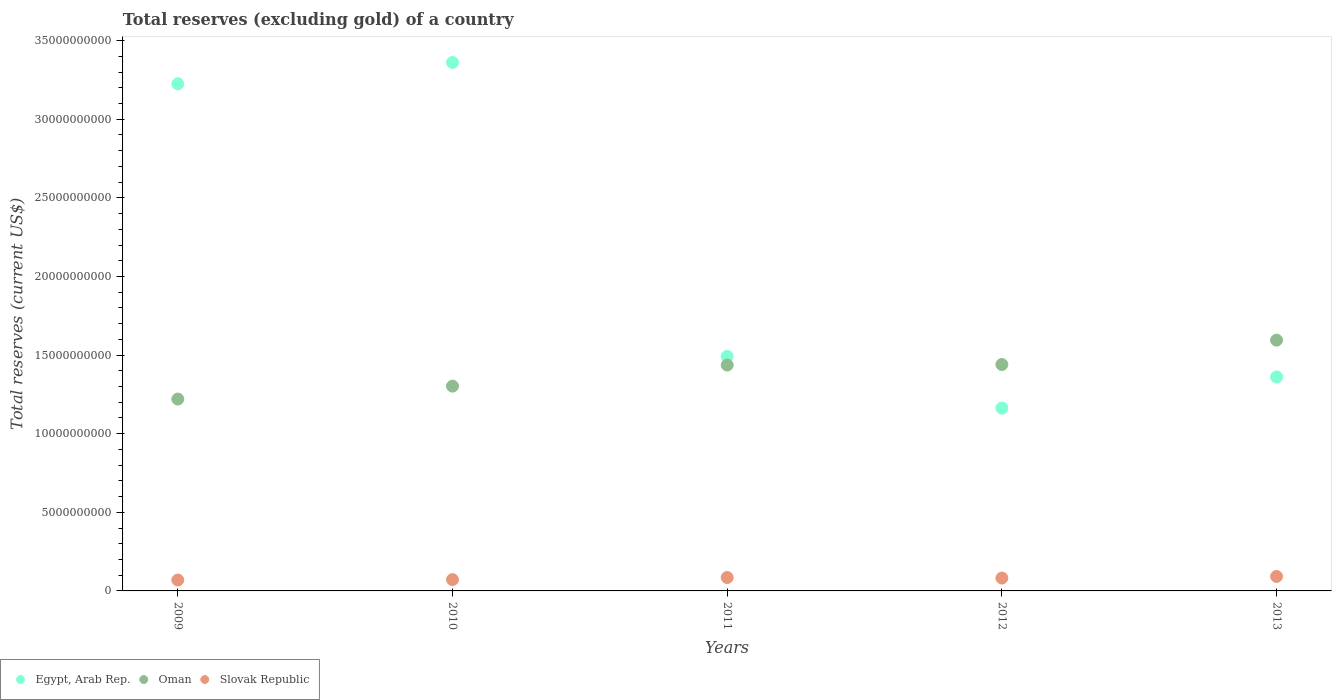What is the total reserves (excluding gold) in Oman in 2009?
Provide a short and direct response. 1.22e+1. Across all years, what is the maximum total reserves (excluding gold) in Egypt, Arab Rep.?
Make the answer very short. 3.36e+1. Across all years, what is the minimum total reserves (excluding gold) in Slovak Republic?
Your response must be concise. 6.92e+08. In which year was the total reserves (excluding gold) in Slovak Republic maximum?
Make the answer very short. 2013. What is the total total reserves (excluding gold) in Oman in the graph?
Make the answer very short. 6.99e+1. What is the difference between the total reserves (excluding gold) in Oman in 2009 and that in 2012?
Give a very brief answer. -2.20e+09. What is the difference between the total reserves (excluding gold) in Oman in 2010 and the total reserves (excluding gold) in Egypt, Arab Rep. in 2009?
Your answer should be compact. -1.92e+1. What is the average total reserves (excluding gold) in Slovak Republic per year?
Your response must be concise. 8.01e+08. In the year 2012, what is the difference between the total reserves (excluding gold) in Egypt, Arab Rep. and total reserves (excluding gold) in Oman?
Your answer should be very brief. -2.77e+09. In how many years, is the total reserves (excluding gold) in Oman greater than 26000000000 US$?
Ensure brevity in your answer.  0. What is the ratio of the total reserves (excluding gold) in Slovak Republic in 2010 to that in 2012?
Give a very brief answer. 0.88. Is the total reserves (excluding gold) in Oman in 2010 less than that in 2013?
Your response must be concise. Yes. Is the difference between the total reserves (excluding gold) in Egypt, Arab Rep. in 2009 and 2010 greater than the difference between the total reserves (excluding gold) in Oman in 2009 and 2010?
Provide a short and direct response. No. What is the difference between the highest and the second highest total reserves (excluding gold) in Oman?
Your answer should be compact. 1.55e+09. What is the difference between the highest and the lowest total reserves (excluding gold) in Egypt, Arab Rep.?
Your response must be concise. 2.20e+1. Is the sum of the total reserves (excluding gold) in Oman in 2010 and 2013 greater than the maximum total reserves (excluding gold) in Egypt, Arab Rep. across all years?
Give a very brief answer. No. Does the total reserves (excluding gold) in Slovak Republic monotonically increase over the years?
Give a very brief answer. No. Is the total reserves (excluding gold) in Egypt, Arab Rep. strictly greater than the total reserves (excluding gold) in Oman over the years?
Make the answer very short. No. Is the total reserves (excluding gold) in Oman strictly less than the total reserves (excluding gold) in Slovak Republic over the years?
Your answer should be compact. No. How many dotlines are there?
Make the answer very short. 3. How many years are there in the graph?
Your answer should be compact. 5. What is the difference between two consecutive major ticks on the Y-axis?
Offer a very short reply. 5.00e+09. What is the title of the graph?
Offer a terse response. Total reserves (excluding gold) of a country. Does "Croatia" appear as one of the legend labels in the graph?
Give a very brief answer. No. What is the label or title of the Y-axis?
Give a very brief answer. Total reserves (current US$). What is the Total reserves (current US$) in Egypt, Arab Rep. in 2009?
Give a very brief answer. 3.23e+1. What is the Total reserves (current US$) of Oman in 2009?
Provide a short and direct response. 1.22e+1. What is the Total reserves (current US$) in Slovak Republic in 2009?
Make the answer very short. 6.92e+08. What is the Total reserves (current US$) in Egypt, Arab Rep. in 2010?
Offer a terse response. 3.36e+1. What is the Total reserves (current US$) of Oman in 2010?
Make the answer very short. 1.30e+1. What is the Total reserves (current US$) in Slovak Republic in 2010?
Give a very brief answer. 7.19e+08. What is the Total reserves (current US$) in Egypt, Arab Rep. in 2011?
Ensure brevity in your answer.  1.49e+1. What is the Total reserves (current US$) in Oman in 2011?
Offer a terse response. 1.44e+1. What is the Total reserves (current US$) of Slovak Republic in 2011?
Offer a very short reply. 8.53e+08. What is the Total reserves (current US$) of Egypt, Arab Rep. in 2012?
Offer a terse response. 1.16e+1. What is the Total reserves (current US$) of Oman in 2012?
Keep it short and to the point. 1.44e+1. What is the Total reserves (current US$) in Slovak Republic in 2012?
Keep it short and to the point. 8.18e+08. What is the Total reserves (current US$) of Egypt, Arab Rep. in 2013?
Your answer should be compact. 1.36e+1. What is the Total reserves (current US$) of Oman in 2013?
Provide a short and direct response. 1.60e+1. What is the Total reserves (current US$) in Slovak Republic in 2013?
Your answer should be compact. 9.22e+08. Across all years, what is the maximum Total reserves (current US$) of Egypt, Arab Rep.?
Provide a succinct answer. 3.36e+1. Across all years, what is the maximum Total reserves (current US$) in Oman?
Offer a terse response. 1.60e+1. Across all years, what is the maximum Total reserves (current US$) in Slovak Republic?
Your answer should be very brief. 9.22e+08. Across all years, what is the minimum Total reserves (current US$) in Egypt, Arab Rep.?
Offer a very short reply. 1.16e+1. Across all years, what is the minimum Total reserves (current US$) of Oman?
Offer a very short reply. 1.22e+1. Across all years, what is the minimum Total reserves (current US$) in Slovak Republic?
Provide a succinct answer. 6.92e+08. What is the total Total reserves (current US$) of Egypt, Arab Rep. in the graph?
Your answer should be very brief. 1.06e+11. What is the total Total reserves (current US$) of Oman in the graph?
Your answer should be very brief. 6.99e+1. What is the total Total reserves (current US$) in Slovak Republic in the graph?
Give a very brief answer. 4.01e+09. What is the difference between the Total reserves (current US$) in Egypt, Arab Rep. in 2009 and that in 2010?
Make the answer very short. -1.36e+09. What is the difference between the Total reserves (current US$) in Oman in 2009 and that in 2010?
Ensure brevity in your answer.  -8.21e+08. What is the difference between the Total reserves (current US$) of Slovak Republic in 2009 and that in 2010?
Make the answer very short. -2.71e+07. What is the difference between the Total reserves (current US$) of Egypt, Arab Rep. in 2009 and that in 2011?
Make the answer very short. 1.73e+1. What is the difference between the Total reserves (current US$) of Oman in 2009 and that in 2011?
Your answer should be compact. -2.16e+09. What is the difference between the Total reserves (current US$) in Slovak Republic in 2009 and that in 2011?
Provide a succinct answer. -1.61e+08. What is the difference between the Total reserves (current US$) in Egypt, Arab Rep. in 2009 and that in 2012?
Your answer should be compact. 2.06e+1. What is the difference between the Total reserves (current US$) of Oman in 2009 and that in 2012?
Give a very brief answer. -2.20e+09. What is the difference between the Total reserves (current US$) of Slovak Republic in 2009 and that in 2012?
Offer a very short reply. -1.26e+08. What is the difference between the Total reserves (current US$) in Egypt, Arab Rep. in 2009 and that in 2013?
Your answer should be very brief. 1.86e+1. What is the difference between the Total reserves (current US$) of Oman in 2009 and that in 2013?
Keep it short and to the point. -3.75e+09. What is the difference between the Total reserves (current US$) in Slovak Republic in 2009 and that in 2013?
Provide a succinct answer. -2.30e+08. What is the difference between the Total reserves (current US$) in Egypt, Arab Rep. in 2010 and that in 2011?
Ensure brevity in your answer.  1.87e+1. What is the difference between the Total reserves (current US$) of Oman in 2010 and that in 2011?
Your answer should be compact. -1.34e+09. What is the difference between the Total reserves (current US$) in Slovak Republic in 2010 and that in 2011?
Provide a short and direct response. -1.34e+08. What is the difference between the Total reserves (current US$) of Egypt, Arab Rep. in 2010 and that in 2012?
Make the answer very short. 2.20e+1. What is the difference between the Total reserves (current US$) of Oman in 2010 and that in 2012?
Your answer should be very brief. -1.38e+09. What is the difference between the Total reserves (current US$) of Slovak Republic in 2010 and that in 2012?
Your answer should be very brief. -9.91e+07. What is the difference between the Total reserves (current US$) of Egypt, Arab Rep. in 2010 and that in 2013?
Keep it short and to the point. 2.00e+1. What is the difference between the Total reserves (current US$) of Oman in 2010 and that in 2013?
Ensure brevity in your answer.  -2.93e+09. What is the difference between the Total reserves (current US$) of Slovak Republic in 2010 and that in 2013?
Make the answer very short. -2.03e+08. What is the difference between the Total reserves (current US$) of Egypt, Arab Rep. in 2011 and that in 2012?
Your answer should be very brief. 3.29e+09. What is the difference between the Total reserves (current US$) of Oman in 2011 and that in 2012?
Make the answer very short. -3.48e+07. What is the difference between the Total reserves (current US$) in Slovak Republic in 2011 and that in 2012?
Your answer should be compact. 3.49e+07. What is the difference between the Total reserves (current US$) of Egypt, Arab Rep. in 2011 and that in 2013?
Your response must be concise. 1.31e+09. What is the difference between the Total reserves (current US$) of Oman in 2011 and that in 2013?
Provide a succinct answer. -1.59e+09. What is the difference between the Total reserves (current US$) of Slovak Republic in 2011 and that in 2013?
Offer a very short reply. -6.86e+07. What is the difference between the Total reserves (current US$) of Egypt, Arab Rep. in 2012 and that in 2013?
Ensure brevity in your answer.  -1.98e+09. What is the difference between the Total reserves (current US$) in Oman in 2012 and that in 2013?
Keep it short and to the point. -1.55e+09. What is the difference between the Total reserves (current US$) in Slovak Republic in 2012 and that in 2013?
Offer a terse response. -1.04e+08. What is the difference between the Total reserves (current US$) in Egypt, Arab Rep. in 2009 and the Total reserves (current US$) in Oman in 2010?
Keep it short and to the point. 1.92e+1. What is the difference between the Total reserves (current US$) in Egypt, Arab Rep. in 2009 and the Total reserves (current US$) in Slovak Republic in 2010?
Your response must be concise. 3.15e+1. What is the difference between the Total reserves (current US$) of Oman in 2009 and the Total reserves (current US$) of Slovak Republic in 2010?
Give a very brief answer. 1.15e+1. What is the difference between the Total reserves (current US$) of Egypt, Arab Rep. in 2009 and the Total reserves (current US$) of Oman in 2011?
Provide a succinct answer. 1.79e+1. What is the difference between the Total reserves (current US$) of Egypt, Arab Rep. in 2009 and the Total reserves (current US$) of Slovak Republic in 2011?
Offer a terse response. 3.14e+1. What is the difference between the Total reserves (current US$) of Oman in 2009 and the Total reserves (current US$) of Slovak Republic in 2011?
Your answer should be compact. 1.13e+1. What is the difference between the Total reserves (current US$) of Egypt, Arab Rep. in 2009 and the Total reserves (current US$) of Oman in 2012?
Your answer should be compact. 1.79e+1. What is the difference between the Total reserves (current US$) in Egypt, Arab Rep. in 2009 and the Total reserves (current US$) in Slovak Republic in 2012?
Offer a very short reply. 3.14e+1. What is the difference between the Total reserves (current US$) in Oman in 2009 and the Total reserves (current US$) in Slovak Republic in 2012?
Keep it short and to the point. 1.14e+1. What is the difference between the Total reserves (current US$) of Egypt, Arab Rep. in 2009 and the Total reserves (current US$) of Oman in 2013?
Offer a very short reply. 1.63e+1. What is the difference between the Total reserves (current US$) in Egypt, Arab Rep. in 2009 and the Total reserves (current US$) in Slovak Republic in 2013?
Your answer should be very brief. 3.13e+1. What is the difference between the Total reserves (current US$) in Oman in 2009 and the Total reserves (current US$) in Slovak Republic in 2013?
Ensure brevity in your answer.  1.13e+1. What is the difference between the Total reserves (current US$) of Egypt, Arab Rep. in 2010 and the Total reserves (current US$) of Oman in 2011?
Offer a terse response. 1.92e+1. What is the difference between the Total reserves (current US$) in Egypt, Arab Rep. in 2010 and the Total reserves (current US$) in Slovak Republic in 2011?
Your response must be concise. 3.28e+1. What is the difference between the Total reserves (current US$) in Oman in 2010 and the Total reserves (current US$) in Slovak Republic in 2011?
Provide a short and direct response. 1.22e+1. What is the difference between the Total reserves (current US$) in Egypt, Arab Rep. in 2010 and the Total reserves (current US$) in Oman in 2012?
Offer a very short reply. 1.92e+1. What is the difference between the Total reserves (current US$) in Egypt, Arab Rep. in 2010 and the Total reserves (current US$) in Slovak Republic in 2012?
Make the answer very short. 3.28e+1. What is the difference between the Total reserves (current US$) of Oman in 2010 and the Total reserves (current US$) of Slovak Republic in 2012?
Offer a very short reply. 1.22e+1. What is the difference between the Total reserves (current US$) in Egypt, Arab Rep. in 2010 and the Total reserves (current US$) in Oman in 2013?
Keep it short and to the point. 1.77e+1. What is the difference between the Total reserves (current US$) of Egypt, Arab Rep. in 2010 and the Total reserves (current US$) of Slovak Republic in 2013?
Your answer should be compact. 3.27e+1. What is the difference between the Total reserves (current US$) in Oman in 2010 and the Total reserves (current US$) in Slovak Republic in 2013?
Give a very brief answer. 1.21e+1. What is the difference between the Total reserves (current US$) in Egypt, Arab Rep. in 2011 and the Total reserves (current US$) in Oman in 2012?
Offer a terse response. 5.16e+08. What is the difference between the Total reserves (current US$) of Egypt, Arab Rep. in 2011 and the Total reserves (current US$) of Slovak Republic in 2012?
Keep it short and to the point. 1.41e+1. What is the difference between the Total reserves (current US$) in Oman in 2011 and the Total reserves (current US$) in Slovak Republic in 2012?
Your answer should be very brief. 1.35e+1. What is the difference between the Total reserves (current US$) of Egypt, Arab Rep. in 2011 and the Total reserves (current US$) of Oman in 2013?
Ensure brevity in your answer.  -1.03e+09. What is the difference between the Total reserves (current US$) in Egypt, Arab Rep. in 2011 and the Total reserves (current US$) in Slovak Republic in 2013?
Provide a succinct answer. 1.40e+1. What is the difference between the Total reserves (current US$) of Oman in 2011 and the Total reserves (current US$) of Slovak Republic in 2013?
Keep it short and to the point. 1.34e+1. What is the difference between the Total reserves (current US$) in Egypt, Arab Rep. in 2012 and the Total reserves (current US$) in Oman in 2013?
Your answer should be very brief. -4.32e+09. What is the difference between the Total reserves (current US$) in Egypt, Arab Rep. in 2012 and the Total reserves (current US$) in Slovak Republic in 2013?
Offer a very short reply. 1.07e+1. What is the difference between the Total reserves (current US$) in Oman in 2012 and the Total reserves (current US$) in Slovak Republic in 2013?
Your response must be concise. 1.35e+1. What is the average Total reserves (current US$) in Egypt, Arab Rep. per year?
Provide a short and direct response. 2.12e+1. What is the average Total reserves (current US$) of Oman per year?
Provide a succinct answer. 1.40e+1. What is the average Total reserves (current US$) in Slovak Republic per year?
Give a very brief answer. 8.01e+08. In the year 2009, what is the difference between the Total reserves (current US$) in Egypt, Arab Rep. and Total reserves (current US$) in Oman?
Offer a terse response. 2.01e+1. In the year 2009, what is the difference between the Total reserves (current US$) in Egypt, Arab Rep. and Total reserves (current US$) in Slovak Republic?
Your response must be concise. 3.16e+1. In the year 2009, what is the difference between the Total reserves (current US$) in Oman and Total reserves (current US$) in Slovak Republic?
Offer a very short reply. 1.15e+1. In the year 2010, what is the difference between the Total reserves (current US$) in Egypt, Arab Rep. and Total reserves (current US$) in Oman?
Keep it short and to the point. 2.06e+1. In the year 2010, what is the difference between the Total reserves (current US$) in Egypt, Arab Rep. and Total reserves (current US$) in Slovak Republic?
Give a very brief answer. 3.29e+1. In the year 2010, what is the difference between the Total reserves (current US$) in Oman and Total reserves (current US$) in Slovak Republic?
Offer a terse response. 1.23e+1. In the year 2011, what is the difference between the Total reserves (current US$) of Egypt, Arab Rep. and Total reserves (current US$) of Oman?
Offer a terse response. 5.50e+08. In the year 2011, what is the difference between the Total reserves (current US$) of Egypt, Arab Rep. and Total reserves (current US$) of Slovak Republic?
Your answer should be very brief. 1.41e+1. In the year 2011, what is the difference between the Total reserves (current US$) of Oman and Total reserves (current US$) of Slovak Republic?
Your answer should be very brief. 1.35e+1. In the year 2012, what is the difference between the Total reserves (current US$) of Egypt, Arab Rep. and Total reserves (current US$) of Oman?
Provide a succinct answer. -2.77e+09. In the year 2012, what is the difference between the Total reserves (current US$) of Egypt, Arab Rep. and Total reserves (current US$) of Slovak Republic?
Make the answer very short. 1.08e+1. In the year 2012, what is the difference between the Total reserves (current US$) in Oman and Total reserves (current US$) in Slovak Republic?
Offer a terse response. 1.36e+1. In the year 2013, what is the difference between the Total reserves (current US$) in Egypt, Arab Rep. and Total reserves (current US$) in Oman?
Your response must be concise. -2.34e+09. In the year 2013, what is the difference between the Total reserves (current US$) in Egypt, Arab Rep. and Total reserves (current US$) in Slovak Republic?
Your answer should be compact. 1.27e+1. In the year 2013, what is the difference between the Total reserves (current US$) in Oman and Total reserves (current US$) in Slovak Republic?
Provide a succinct answer. 1.50e+1. What is the ratio of the Total reserves (current US$) of Egypt, Arab Rep. in 2009 to that in 2010?
Offer a terse response. 0.96. What is the ratio of the Total reserves (current US$) of Oman in 2009 to that in 2010?
Offer a terse response. 0.94. What is the ratio of the Total reserves (current US$) in Slovak Republic in 2009 to that in 2010?
Offer a very short reply. 0.96. What is the ratio of the Total reserves (current US$) in Egypt, Arab Rep. in 2009 to that in 2011?
Keep it short and to the point. 2.16. What is the ratio of the Total reserves (current US$) of Oman in 2009 to that in 2011?
Ensure brevity in your answer.  0.85. What is the ratio of the Total reserves (current US$) in Slovak Republic in 2009 to that in 2011?
Provide a succinct answer. 0.81. What is the ratio of the Total reserves (current US$) in Egypt, Arab Rep. in 2009 to that in 2012?
Offer a very short reply. 2.77. What is the ratio of the Total reserves (current US$) in Oman in 2009 to that in 2012?
Keep it short and to the point. 0.85. What is the ratio of the Total reserves (current US$) of Slovak Republic in 2009 to that in 2012?
Offer a very short reply. 0.85. What is the ratio of the Total reserves (current US$) of Egypt, Arab Rep. in 2009 to that in 2013?
Your answer should be very brief. 2.37. What is the ratio of the Total reserves (current US$) in Oman in 2009 to that in 2013?
Your answer should be compact. 0.77. What is the ratio of the Total reserves (current US$) in Slovak Republic in 2009 to that in 2013?
Your response must be concise. 0.75. What is the ratio of the Total reserves (current US$) in Egypt, Arab Rep. in 2010 to that in 2011?
Your answer should be compact. 2.25. What is the ratio of the Total reserves (current US$) of Oman in 2010 to that in 2011?
Give a very brief answer. 0.91. What is the ratio of the Total reserves (current US$) of Slovak Republic in 2010 to that in 2011?
Your answer should be very brief. 0.84. What is the ratio of the Total reserves (current US$) in Egypt, Arab Rep. in 2010 to that in 2012?
Provide a succinct answer. 2.89. What is the ratio of the Total reserves (current US$) in Oman in 2010 to that in 2012?
Make the answer very short. 0.9. What is the ratio of the Total reserves (current US$) in Slovak Republic in 2010 to that in 2012?
Provide a succinct answer. 0.88. What is the ratio of the Total reserves (current US$) of Egypt, Arab Rep. in 2010 to that in 2013?
Provide a succinct answer. 2.47. What is the ratio of the Total reserves (current US$) in Oman in 2010 to that in 2013?
Offer a very short reply. 0.82. What is the ratio of the Total reserves (current US$) in Slovak Republic in 2010 to that in 2013?
Provide a succinct answer. 0.78. What is the ratio of the Total reserves (current US$) of Egypt, Arab Rep. in 2011 to that in 2012?
Your answer should be very brief. 1.28. What is the ratio of the Total reserves (current US$) in Oman in 2011 to that in 2012?
Offer a terse response. 1. What is the ratio of the Total reserves (current US$) of Slovak Republic in 2011 to that in 2012?
Offer a terse response. 1.04. What is the ratio of the Total reserves (current US$) of Egypt, Arab Rep. in 2011 to that in 2013?
Your response must be concise. 1.1. What is the ratio of the Total reserves (current US$) of Oman in 2011 to that in 2013?
Provide a short and direct response. 0.9. What is the ratio of the Total reserves (current US$) in Slovak Republic in 2011 to that in 2013?
Provide a short and direct response. 0.93. What is the ratio of the Total reserves (current US$) in Egypt, Arab Rep. in 2012 to that in 2013?
Provide a short and direct response. 0.85. What is the ratio of the Total reserves (current US$) of Oman in 2012 to that in 2013?
Give a very brief answer. 0.9. What is the ratio of the Total reserves (current US$) of Slovak Republic in 2012 to that in 2013?
Provide a short and direct response. 0.89. What is the difference between the highest and the second highest Total reserves (current US$) in Egypt, Arab Rep.?
Provide a short and direct response. 1.36e+09. What is the difference between the highest and the second highest Total reserves (current US$) of Oman?
Your answer should be very brief. 1.55e+09. What is the difference between the highest and the second highest Total reserves (current US$) of Slovak Republic?
Your response must be concise. 6.86e+07. What is the difference between the highest and the lowest Total reserves (current US$) in Egypt, Arab Rep.?
Your answer should be compact. 2.20e+1. What is the difference between the highest and the lowest Total reserves (current US$) of Oman?
Your response must be concise. 3.75e+09. What is the difference between the highest and the lowest Total reserves (current US$) in Slovak Republic?
Your response must be concise. 2.30e+08. 